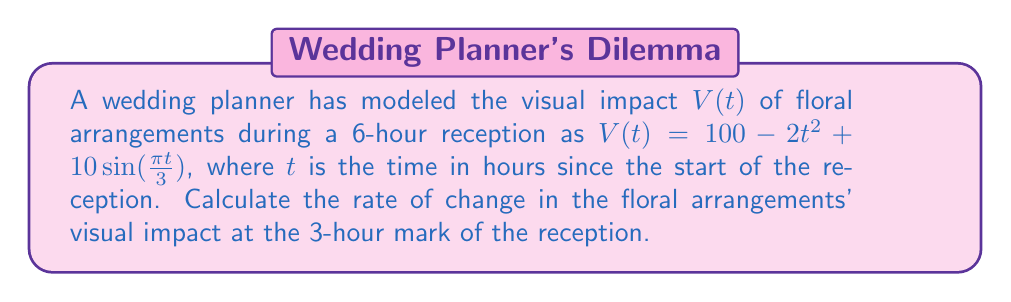Give your solution to this math problem. To find the rate of change in the floral arrangements' visual impact at the 3-hour mark, we need to calculate the derivative of $V(t)$ and evaluate it at $t=3$.

Step 1: Find the derivative of $V(t)$
$$V'(t) = \frac{d}{dt}[100 - 2t^2 + 10\sin(\frac{\pi t}{3})]$$
$$V'(t) = -4t + 10\cos(\frac{\pi t}{3}) \cdot \frac{\pi}{3}$$

Step 2: Simplify the derivative
$$V'(t) = -4t + \frac{10\pi}{3}\cos(\frac{\pi t}{3})$$

Step 3: Evaluate $V'(t)$ at $t=3$
$$V'(3) = -4(3) + \frac{10\pi}{3}\cos(\frac{\pi \cdot 3}{3})$$
$$V'(3) = -12 + \frac{10\pi}{3}\cos(\pi)$$

Step 4: Simplify the expression
$$V'(3) = -12 + \frac{10\pi}{3}(-1)$$
$$V'(3) = -12 - \frac{10\pi}{3}$$

Step 5: Calculate the final value
$$V'(3) \approx -22.47$$
Answer: $-22.47$ units/hour 